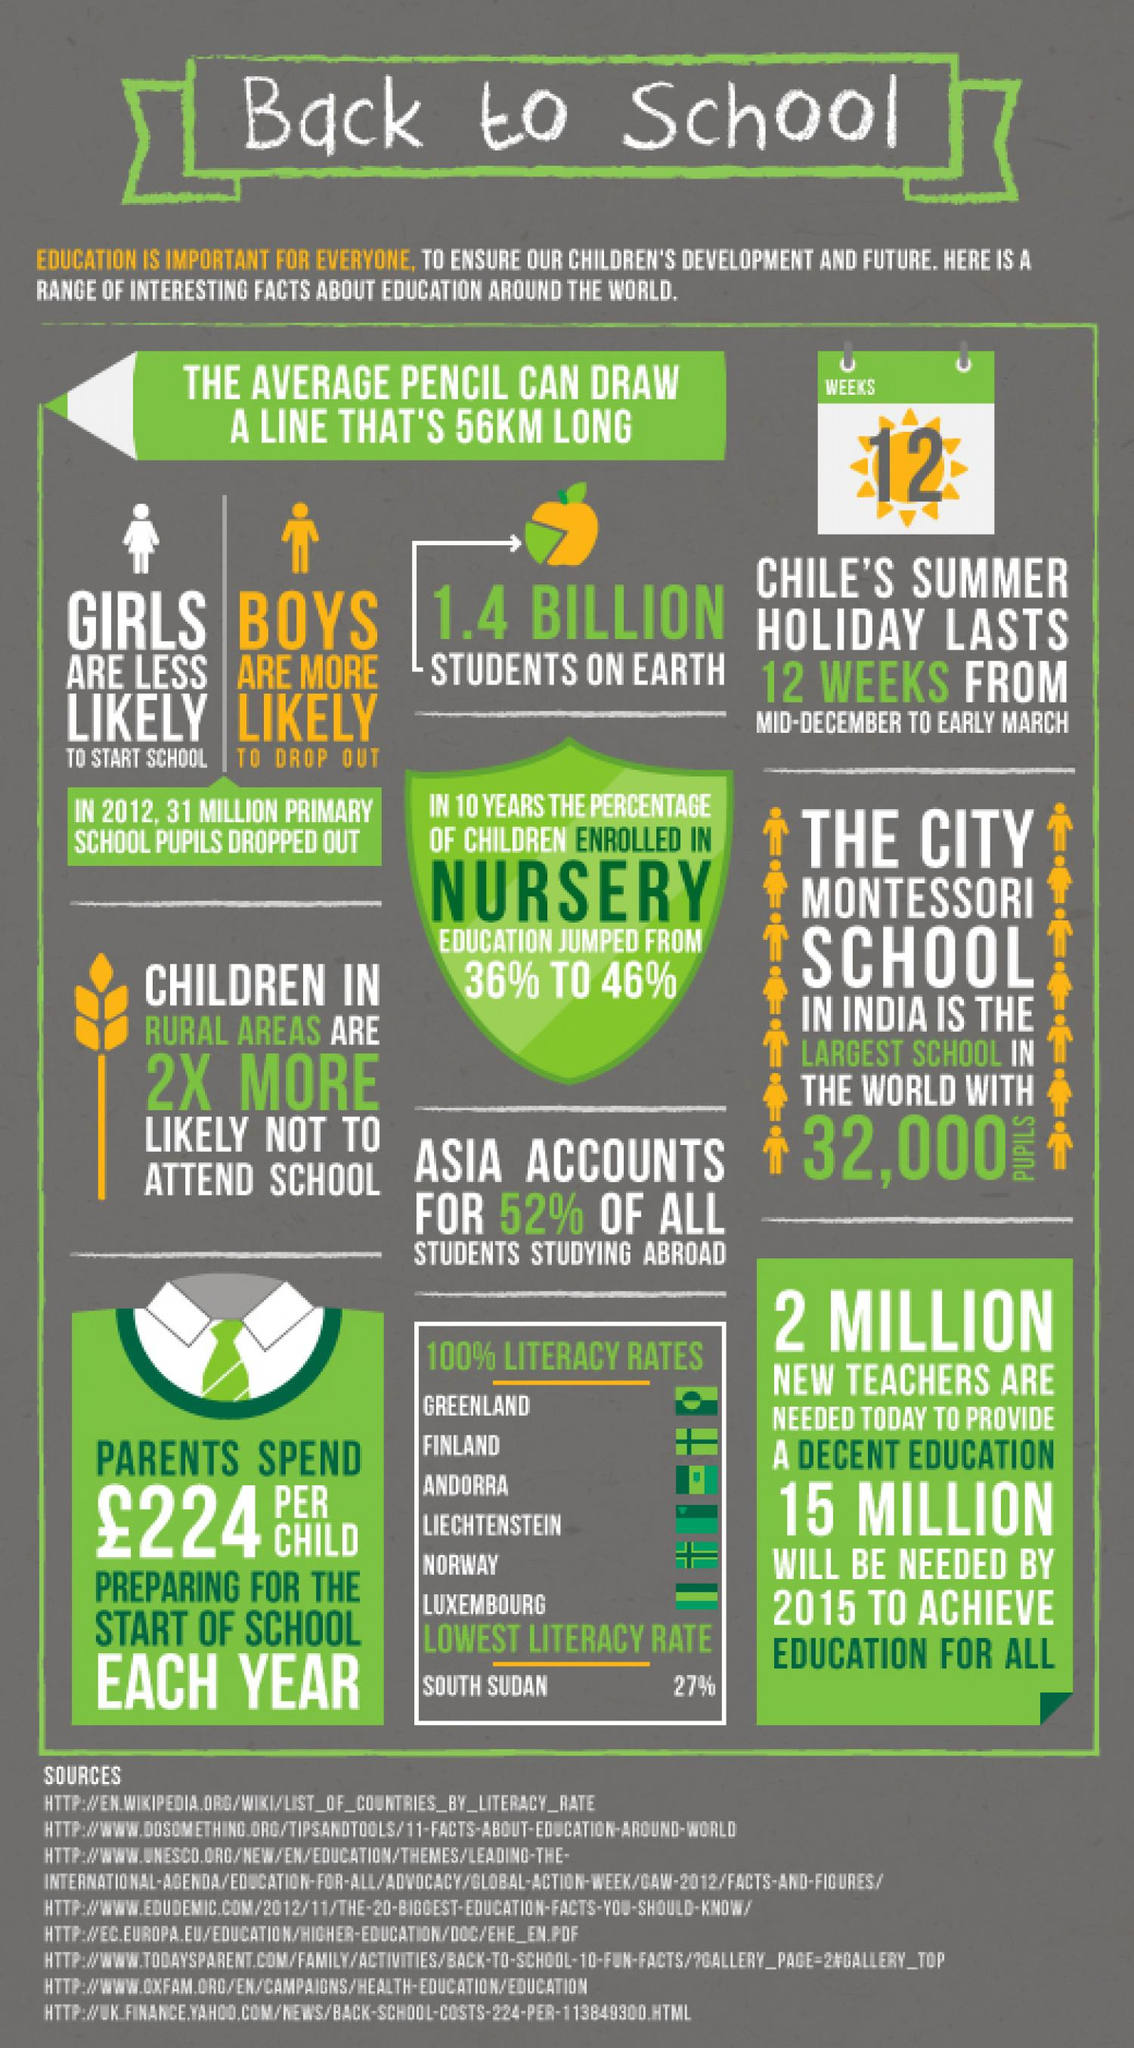Draw attention to some important aspects in this diagram. The enrollment in nursery has increased by 10% in the last decade. There are approximately 1.4 billion students on Earth. According to statistics, a higher percentage of students from Asia are choosing to study abroad compared to students from other continents. South Sudan has the lowest literacy rate among all regions. The expenditure for each child for the beginning of an academic year is £224. 